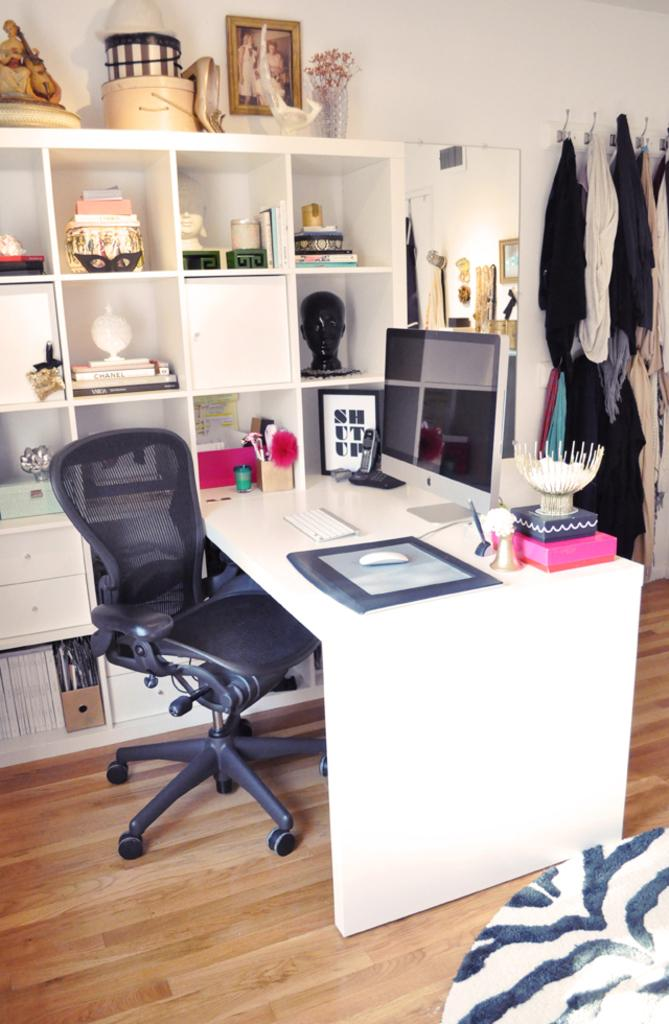<image>
Summarize the visual content of the image. office desk with a framed picture that has "shut up"  next to monitor 